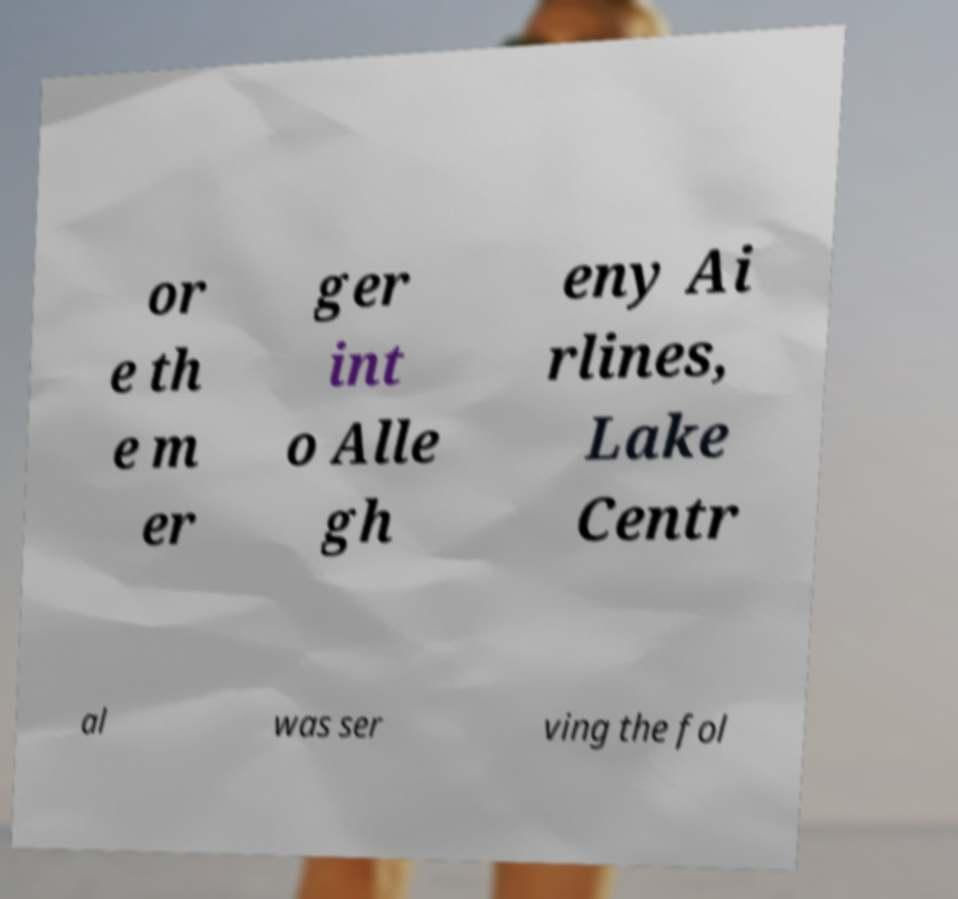Please identify and transcribe the text found in this image. or e th e m er ger int o Alle gh eny Ai rlines, Lake Centr al was ser ving the fol 